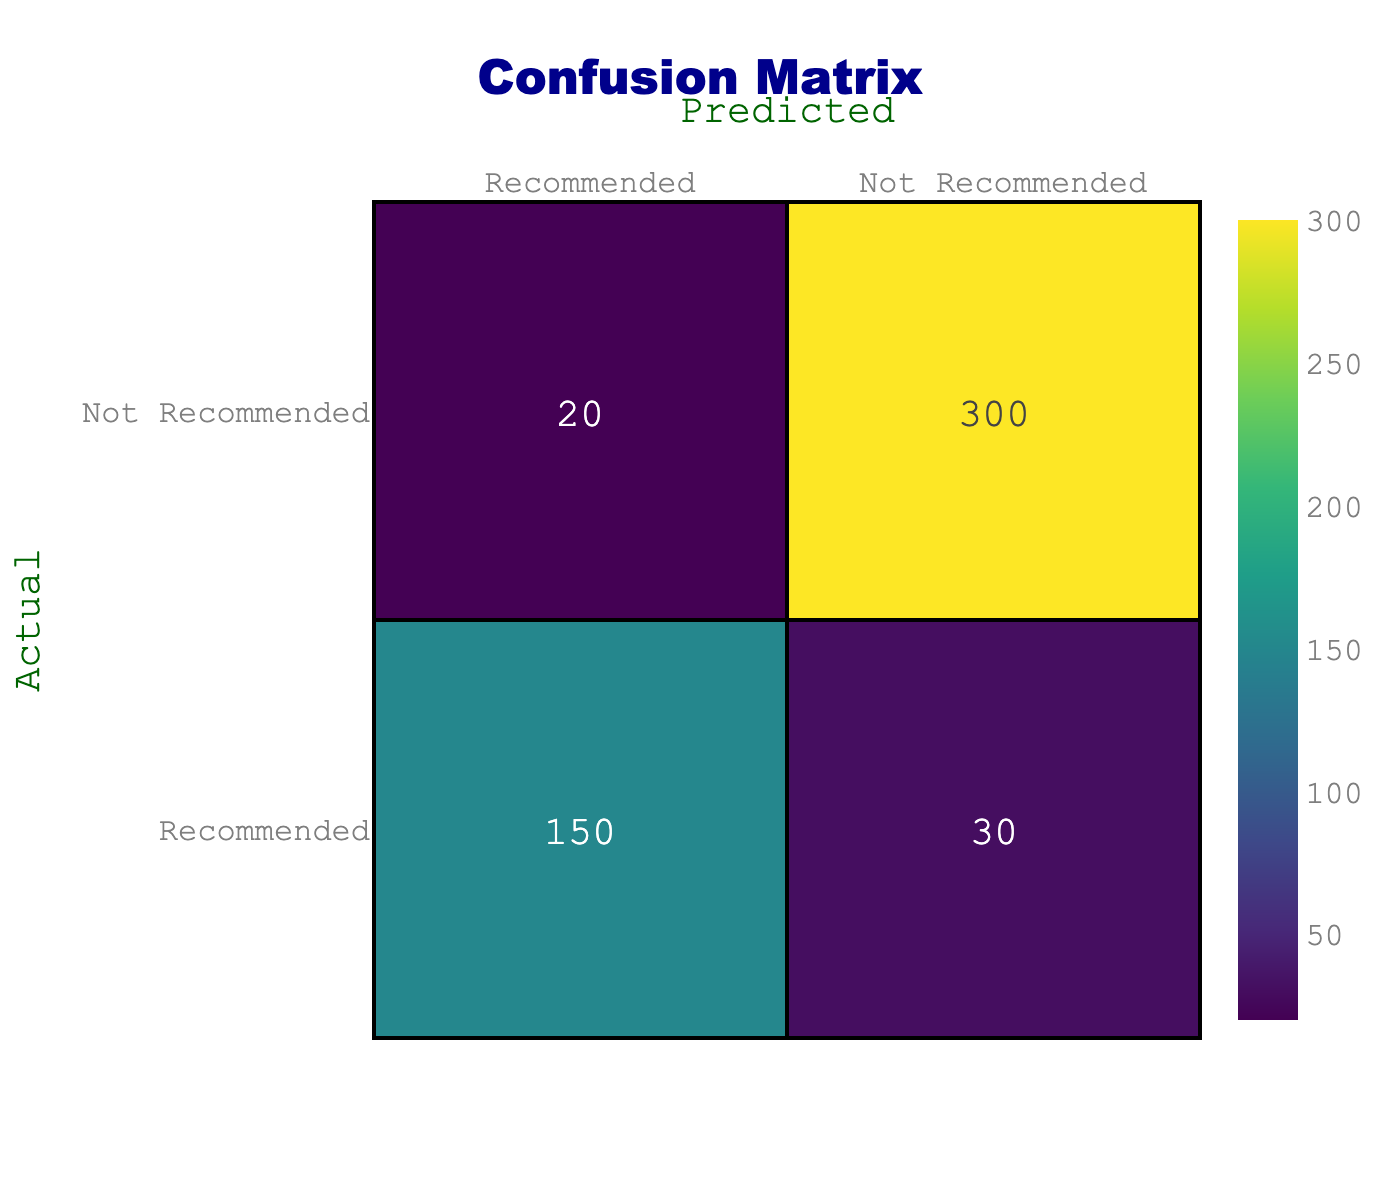What is the total number of instances classified as Recommended? To find the total classified as Recommended, we look at the values in the Recommended row. Adding these, we have 150 (True Positives) + 30 (False Negatives) = 180.
Answer: 180 What is the number of instances incorrectly classified as Not Recommended? The number of instances wrongly classified as Not Recommended can be found in the Not Recommended row, where there are 20 instances classified as Not Recommended when they should have been Recommended.
Answer: 20 What is the total number of instances in the model? To find the total number of instances, we sum all values in the confusion matrix: 150 (True Positives) + 30 (False Negatives) + 20 (False Positives) + 300 (True Negatives) = 500.
Answer: 500 Is the number of actual negatives greater than the number of actual positives? Yes, the actual negatives (300 True Negatives + 20 False Positives = 320) are greater than the actual positives (150 True Positives + 30 False Negatives = 180).
Answer: Yes What is the recall for the Recommended category? Recall is calculated as True Positives / (True Positives + False Negatives). The calculation here would be 150 / (150 + 30) = 150 / 180 = 0.8333 or approximately 83.33%.
Answer: 83.33% How many total instances are classified as Recommended or Not Recommended? To find the total classified as either, we add the values from the Recommended and Not Recommended columns: 150 + 30 + 20 + 300 = 500.
Answer: 500 What percentage of the total predictions were correctly classified as Recommended? To calculate the percentage of correct predictions for Recommended, we use the formula: (True Positives / Total Predictions) * 100. This results in (150 / 500) * 100 = 30%.
Answer: 30% What is the precision for the Recommended category? Precision is calculated as True Positives / (True Positives + False Positives). Here, it's calculated as 150 / (150 + 20) = 150 / 170 = 0.8824, or approximately 88.24%.
Answer: 88.24% How many more instances were correctly identified in the Not Recommended category compared to the Recommended category? The count for correctly identified Not Recommended is 300 (True Negatives) and for Recommended is 150 (True Positives). The difference is 300 - 150 = 150.
Answer: 150 